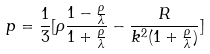Convert formula to latex. <formula><loc_0><loc_0><loc_500><loc_500>p = \frac { 1 } { 3 } [ \rho \frac { 1 - \frac { \rho } { \lambda } } { 1 + \frac { \rho } { \lambda } } - \frac { R } { k ^ { 2 } ( 1 + \frac { \rho } { \lambda } ) } ]</formula> 